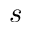<formula> <loc_0><loc_0><loc_500><loc_500>s</formula> 